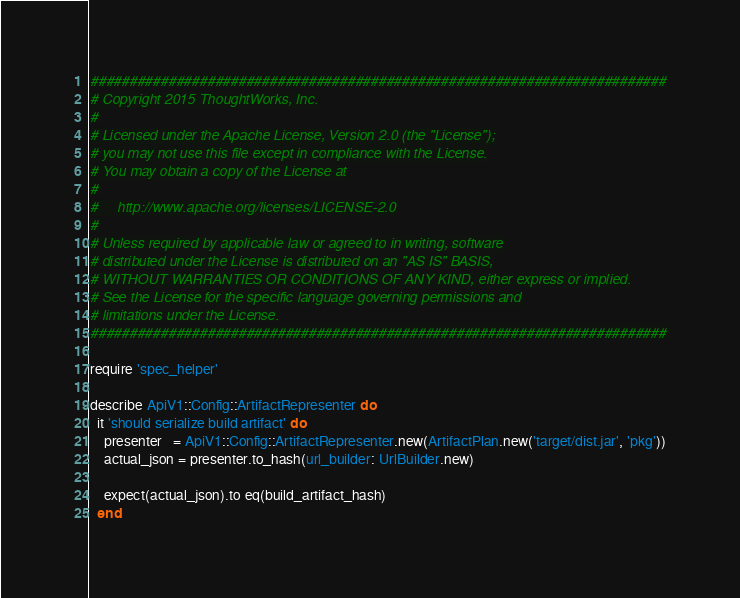<code> <loc_0><loc_0><loc_500><loc_500><_Ruby_>##########################################################################
# Copyright 2015 ThoughtWorks, Inc.
#
# Licensed under the Apache License, Version 2.0 (the "License");
# you may not use this file except in compliance with the License.
# You may obtain a copy of the License at
#
#     http://www.apache.org/licenses/LICENSE-2.0
#
# Unless required by applicable law or agreed to in writing, software
# distributed under the License is distributed on an "AS IS" BASIS,
# WITHOUT WARRANTIES OR CONDITIONS OF ANY KIND, either express or implied.
# See the License for the specific language governing permissions and
# limitations under the License.
##########################################################################

require 'spec_helper'

describe ApiV1::Config::ArtifactRepresenter do
  it 'should serialize build artifact' do
    presenter   = ApiV1::Config::ArtifactRepresenter.new(ArtifactPlan.new('target/dist.jar', 'pkg'))
    actual_json = presenter.to_hash(url_builder: UrlBuilder.new)

    expect(actual_json).to eq(build_artifact_hash)
  end
</code> 